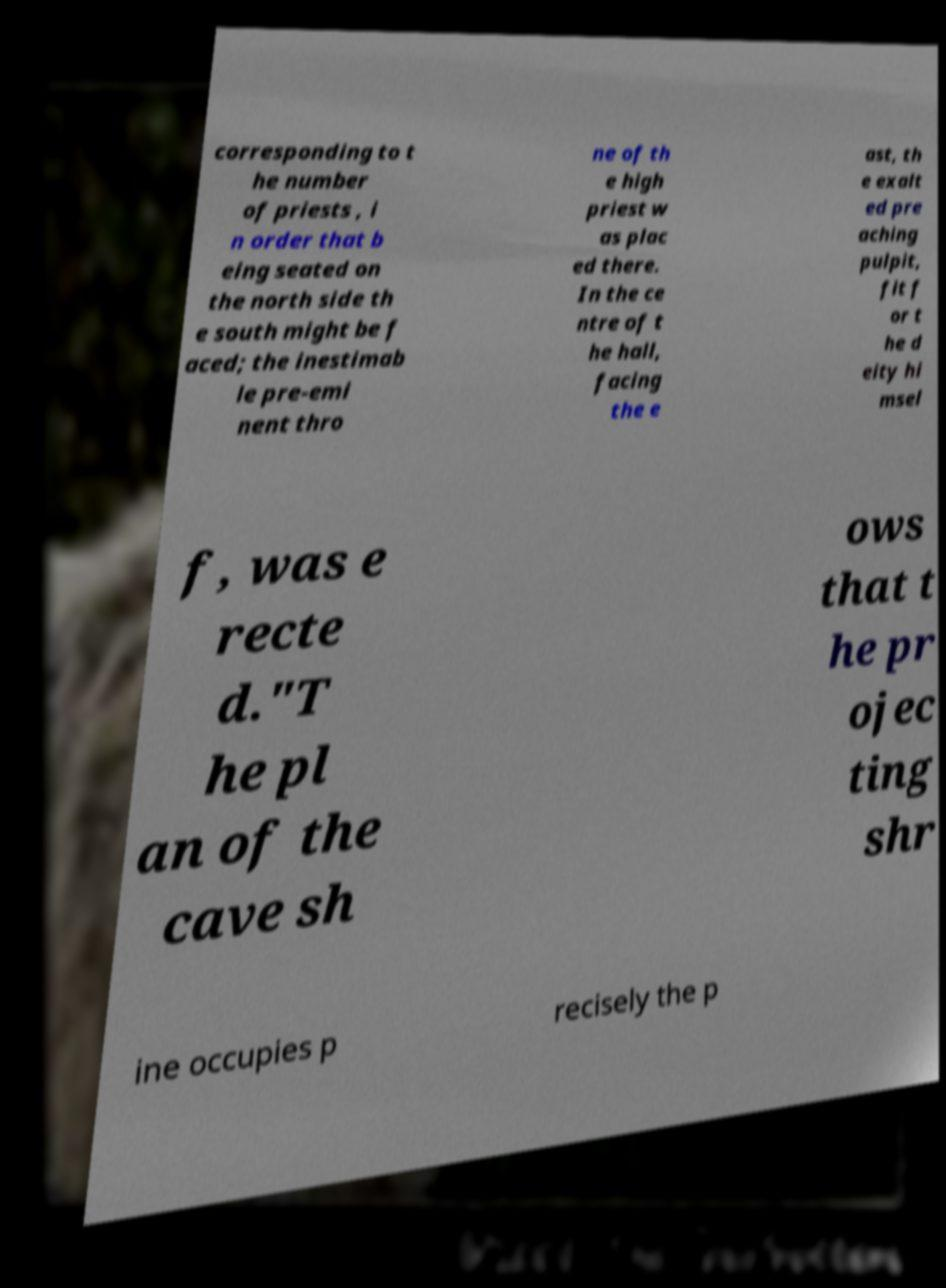Could you assist in decoding the text presented in this image and type it out clearly? corresponding to t he number of priests , i n order that b eing seated on the north side th e south might be f aced; the inestimab le pre-emi nent thro ne of th e high priest w as plac ed there. In the ce ntre of t he hall, facing the e ast, th e exalt ed pre aching pulpit, fit f or t he d eity hi msel f, was e recte d."T he pl an of the cave sh ows that t he pr ojec ting shr ine occupies p recisely the p 